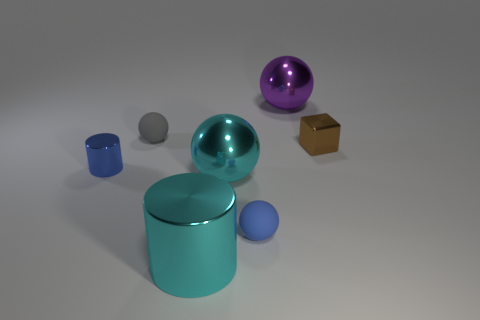What number of tiny things are green shiny cylinders or blue matte things?
Your answer should be very brief. 1. Does the matte object that is in front of the metallic cube have the same shape as the small blue object on the left side of the small gray rubber sphere?
Your answer should be very brief. No. What is the size of the blue object that is behind the tiny blue thing to the right of the large shiny ball in front of the big purple thing?
Provide a short and direct response. Small. What size is the metal sphere on the left side of the large purple shiny sphere?
Give a very brief answer. Large. There is a tiny blue object that is on the right side of the gray matte sphere; what material is it?
Give a very brief answer. Rubber. How many brown things are cylinders or large cylinders?
Offer a terse response. 0. Do the tiny block and the small ball that is behind the tiny cube have the same material?
Make the answer very short. No. Are there an equal number of blue rubber balls on the right side of the tiny brown thing and gray balls on the left side of the small gray sphere?
Ensure brevity in your answer.  Yes. There is a cyan metal cylinder; is its size the same as the sphere on the right side of the tiny blue matte thing?
Ensure brevity in your answer.  Yes. Is the number of small metallic things that are on the left side of the blue rubber object greater than the number of small blue matte balls?
Provide a succinct answer. No. 